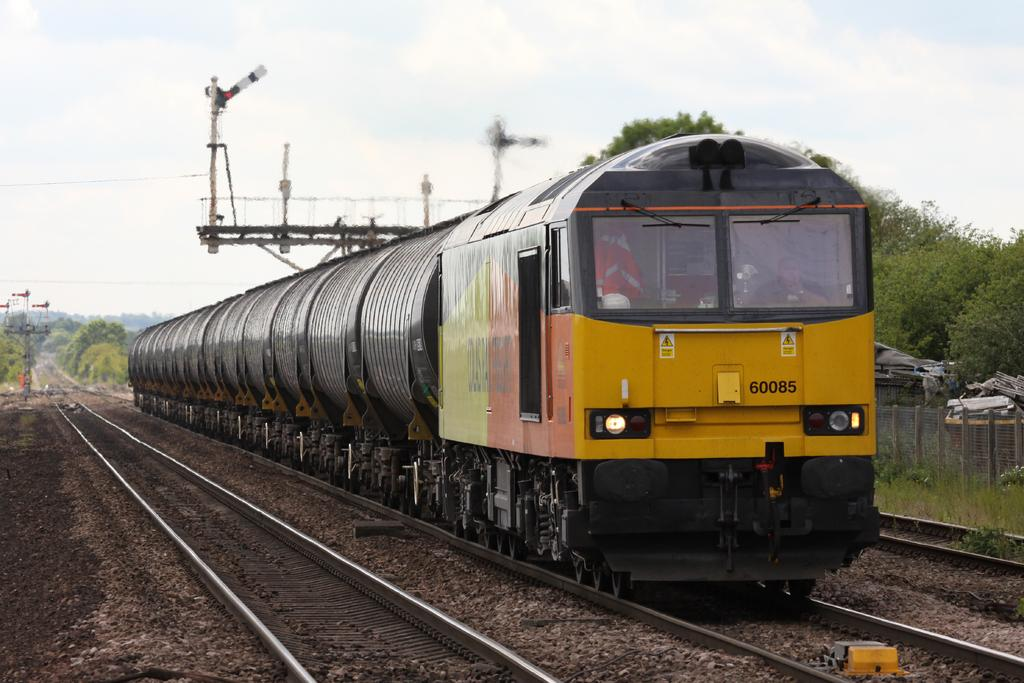What is the main subject of the image? The main subject of the image is a train. What is the train doing in the image? The train is moving on a track. What can be seen in the background of the image? There are trees, sky, and electrical poles visible in the background of the image. What type of ring is being worn by the train in the image? There is no ring present in the image, as the subject is a train, not a person. 